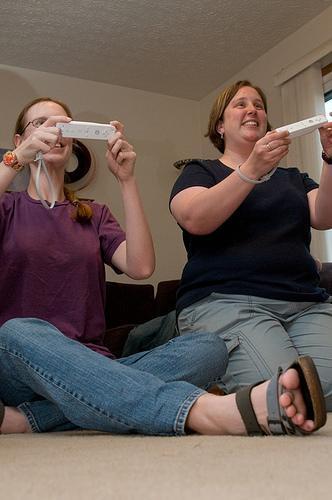How many people are shown?
Give a very brief answer. 2. How many people can you see?
Give a very brief answer. 2. 